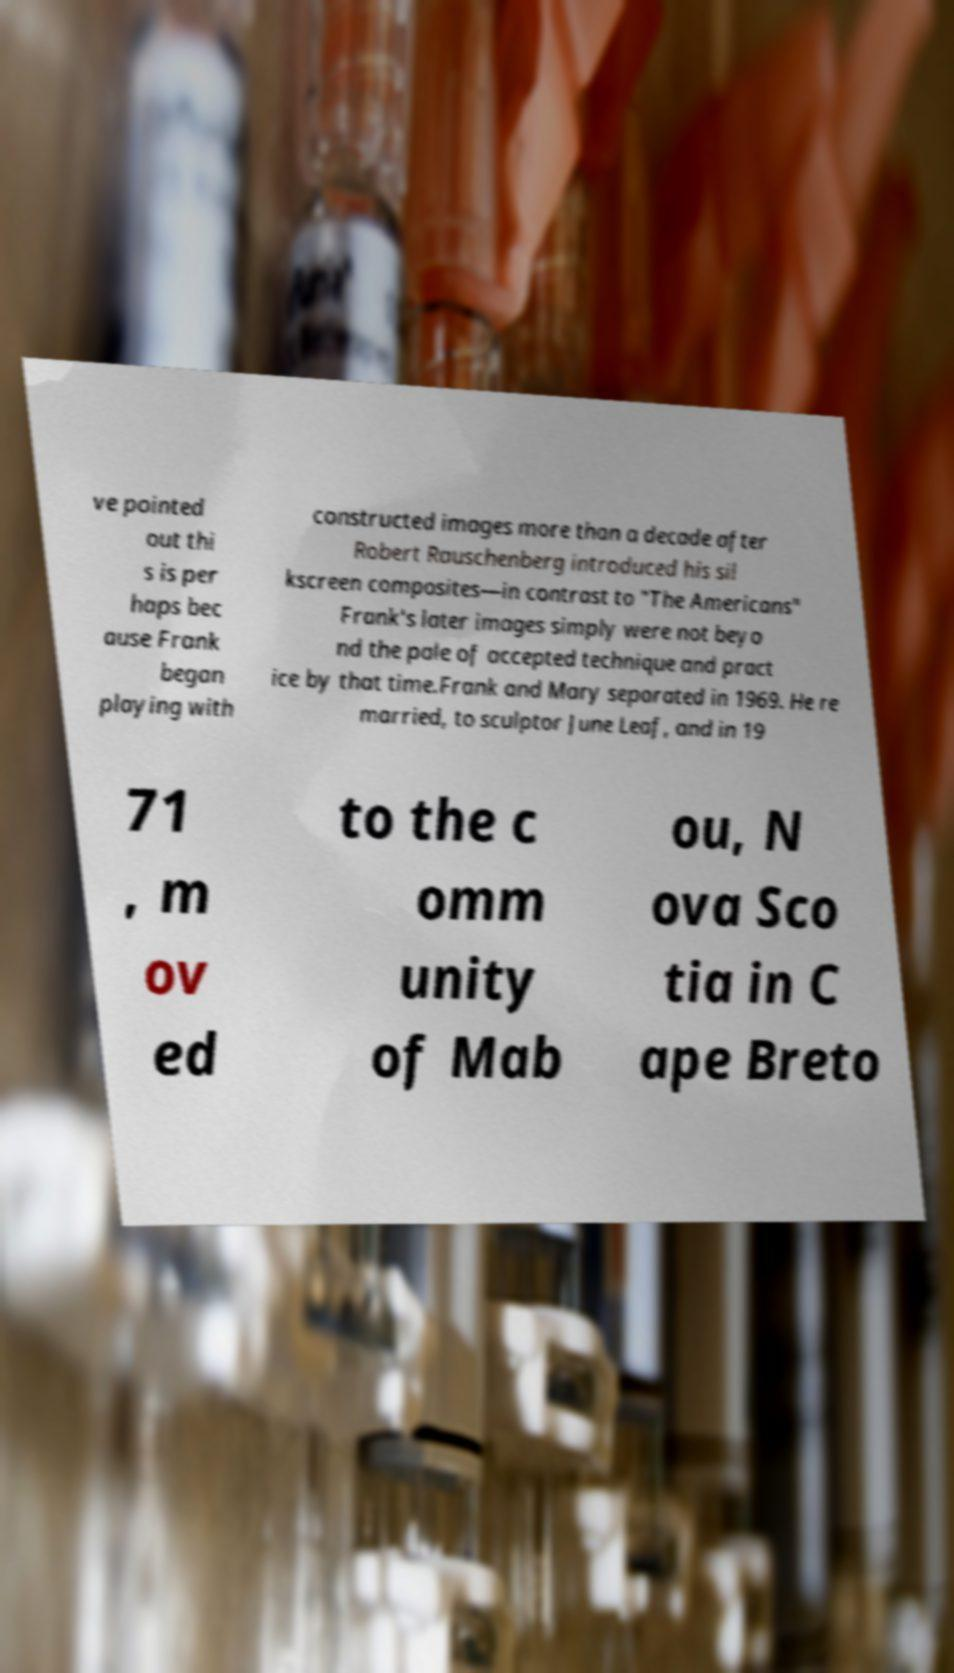Please read and relay the text visible in this image. What does it say? ve pointed out thi s is per haps bec ause Frank began playing with constructed images more than a decade after Robert Rauschenberg introduced his sil kscreen composites—in contrast to "The Americans" Frank's later images simply were not beyo nd the pale of accepted technique and pract ice by that time.Frank and Mary separated in 1969. He re married, to sculptor June Leaf, and in 19 71 , m ov ed to the c omm unity of Mab ou, N ova Sco tia in C ape Breto 